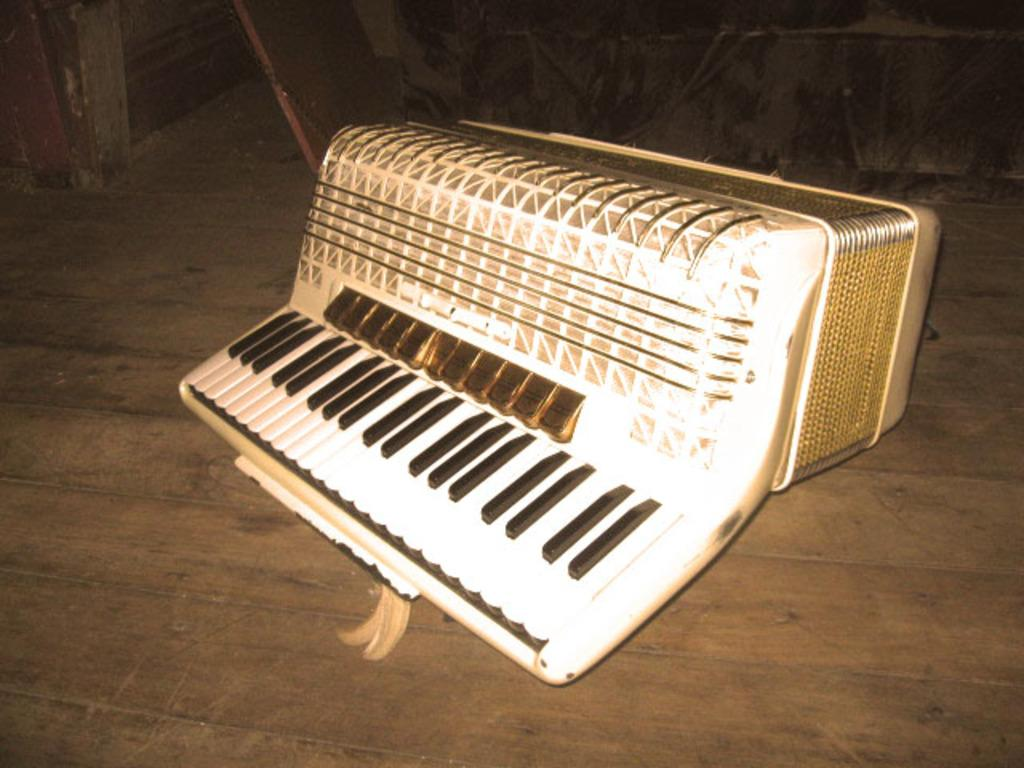What object in the image is used for making music? There is a musical instrument in the image. Where is the musical instrument located? The musical instrument is on the floor. What can be observed about the lighting in the image? The background of the image appears to be dark. How many children are visible in the image, and what is their estimated profit from playing the musical instrument? There are no children visible in the image, and therefore no profit can be estimated. 